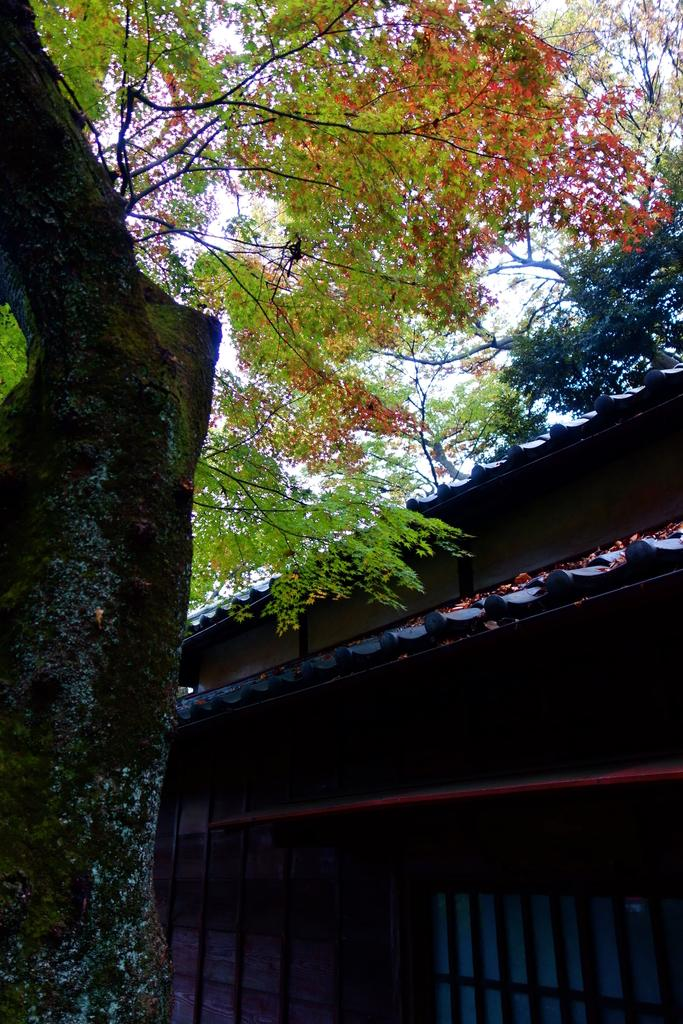What type of natural element can be seen towards the left side of the image? There is a tree towards the left side of the image. What type of structure can be seen at the bottom right side of the image? There is a house at the bottom right side of the image. Where is the camera located in the image? There is no camera present in the image. What type of object is in the middle of the image? The facts provided do not mention any object in the middle of the image. 